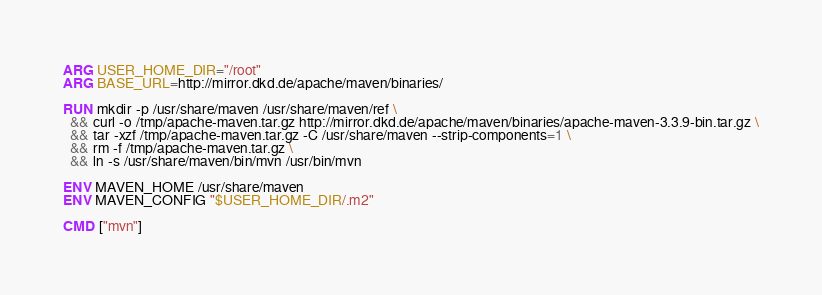Convert code to text. <code><loc_0><loc_0><loc_500><loc_500><_Dockerfile_>ARG USER_HOME_DIR="/root"
ARG BASE_URL=http://mirror.dkd.de/apache/maven/binaries/

RUN mkdir -p /usr/share/maven /usr/share/maven/ref \
  && curl -o /tmp/apache-maven.tar.gz http://mirror.dkd.de/apache/maven/binaries/apache-maven-3.3.9-bin.tar.gz \
  && tar -xzf /tmp/apache-maven.tar.gz -C /usr/share/maven --strip-components=1 \
  && rm -f /tmp/apache-maven.tar.gz \
  && ln -s /usr/share/maven/bin/mvn /usr/bin/mvn

ENV MAVEN_HOME /usr/share/maven
ENV MAVEN_CONFIG "$USER_HOME_DIR/.m2"

CMD ["mvn"]</code> 